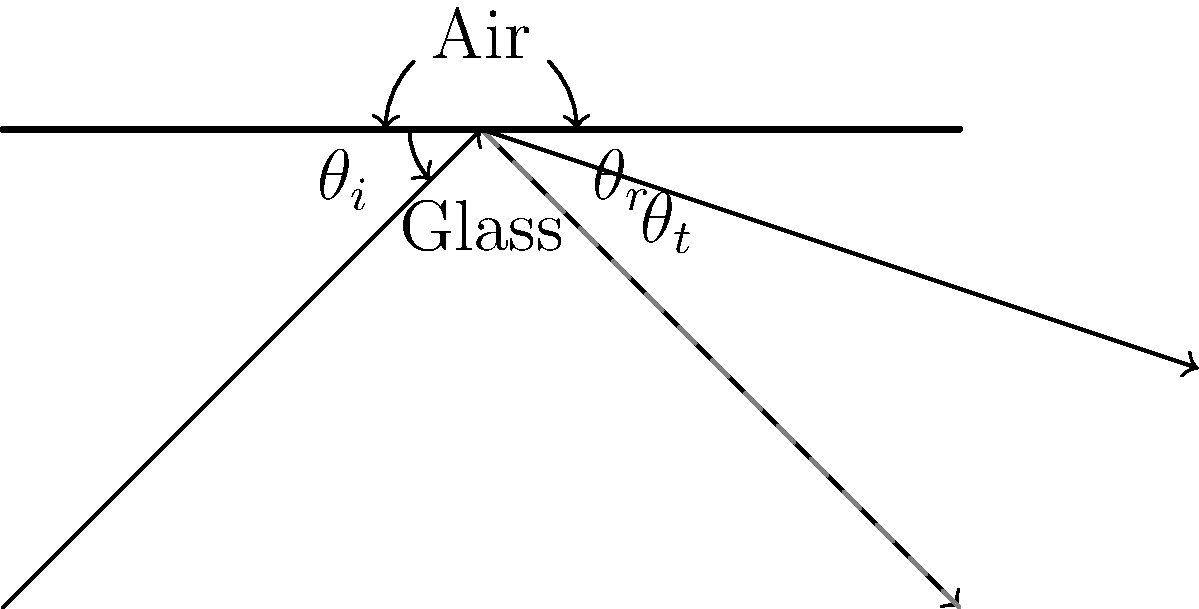You're designing a hidden compartment for a special delivery. To ensure its contents remain undetected, you need to understand how light behaves when passing through different materials. If light travels from air into glass with an incident angle $\theta_i = 45°$ and a refractive index of glass $n_g = 1.5$, what is the angle of refraction $\theta_t$ inside the glass? To solve this problem, we'll use Snell's law, which describes how light refracts when passing from one medium to another:

1) Snell's law states: $n_1 \sin(\theta_1) = n_2 \sin(\theta_2)$

2) In this case:
   $n_1 = 1$ (refractive index of air)
   $n_2 = 1.5$ (refractive index of glass)
   $\theta_1 = 45°$ (incident angle)
   $\theta_2 = \theta_t$ (angle of refraction, which we need to find)

3) Substituting these values into Snell's law:
   $1 \cdot \sin(45°) = 1.5 \cdot \sin(\theta_t)$

4) Simplify:
   $\sin(45°) = 1.5 \sin(\theta_t)$

5) We know that $\sin(45°) = \frac{1}{\sqrt{2}} \approx 0.7071$

6) So our equation becomes:
   $0.7071 = 1.5 \sin(\theta_t)$

7) Solve for $\sin(\theta_t)$:
   $\sin(\theta_t) = \frac{0.7071}{1.5} \approx 0.4714$

8) To get $\theta_t$, we need to take the inverse sine (arcsin) of both sides:
   $\theta_t = \arcsin(0.4714) \approx 28.1°$

Therefore, the angle of refraction $\theta_t$ inside the glass is approximately 28.1°.
Answer: $28.1°$ 